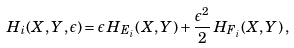<formula> <loc_0><loc_0><loc_500><loc_500>H _ { i } ( X , Y , \epsilon ) = \epsilon \, H _ { E _ { i } } ( X , Y ) + \frac { \epsilon ^ { 2 } } { 2 } \, H _ { F _ { i } } ( X , Y ) \, ,</formula> 